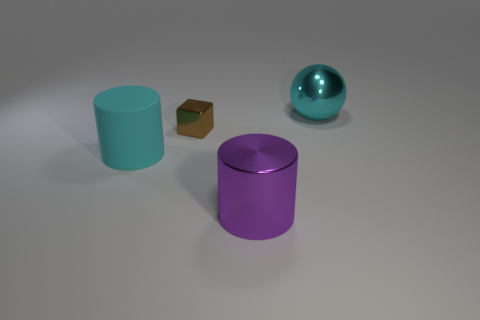Is there anything else that is the same size as the brown object?
Provide a succinct answer. No. There is a big purple object that is the same material as the brown object; what shape is it?
Offer a very short reply. Cylinder. Is there any other thing of the same color as the metal sphere?
Give a very brief answer. Yes. What number of big shiny things are on the right side of the big metal thing that is in front of the cyan object that is behind the big cyan matte object?
Ensure brevity in your answer.  1. How many cyan objects are small rubber things or big metal balls?
Give a very brief answer. 1. Do the rubber object and the purple metal thing that is in front of the tiny metallic cube have the same size?
Offer a very short reply. Yes. There is another big purple thing that is the same shape as the big matte thing; what is its material?
Offer a terse response. Metal. How many other objects are there of the same size as the purple thing?
Provide a succinct answer. 2. The big object to the left of the thing in front of the cyan matte object that is in front of the tiny brown block is what shape?
Keep it short and to the point. Cylinder. There is a thing that is on the left side of the purple metallic thing and behind the matte object; what shape is it?
Offer a terse response. Cube. 